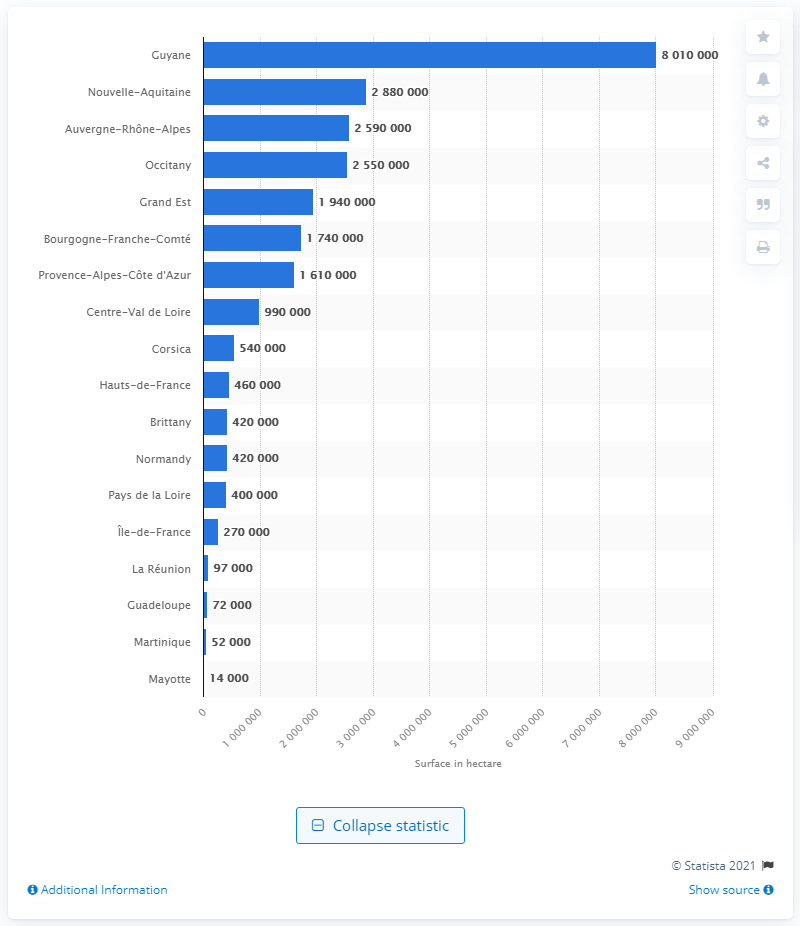Draw attention to some important aspects in this diagram. Nouvelle-Aquitaine has the largest forest cover in France. The least forested area in France is located in the Pays de la Loire region. The largest French forest in the overseas department of Guyane is located in the region. 